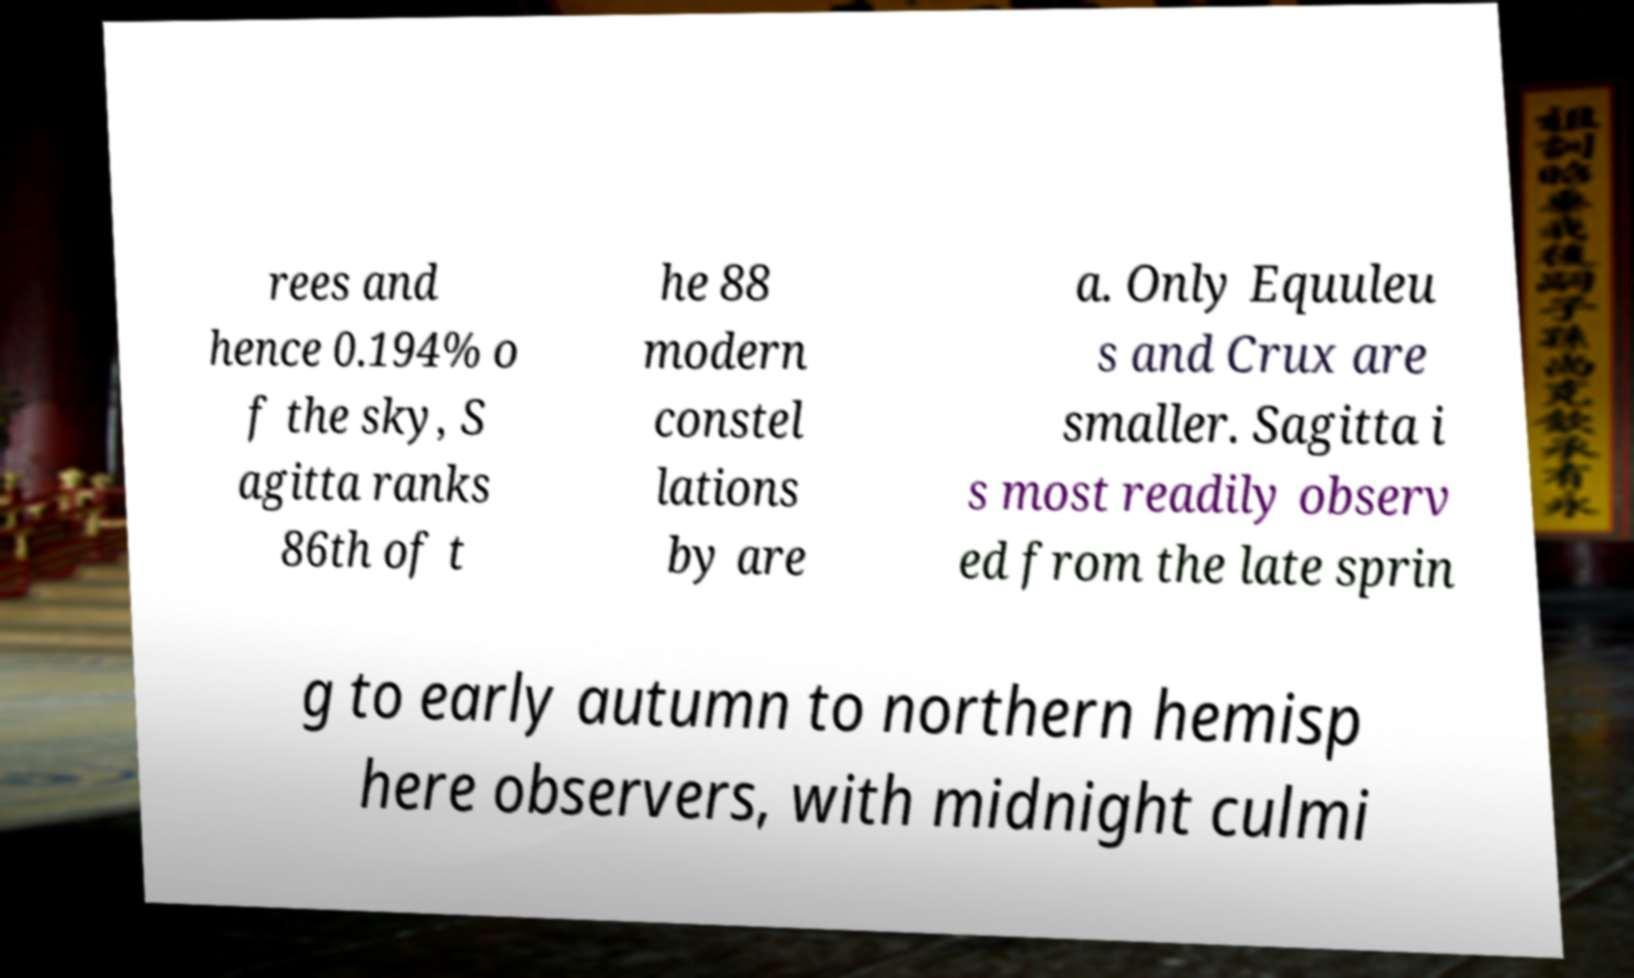I need the written content from this picture converted into text. Can you do that? rees and hence 0.194% o f the sky, S agitta ranks 86th of t he 88 modern constel lations by are a. Only Equuleu s and Crux are smaller. Sagitta i s most readily observ ed from the late sprin g to early autumn to northern hemisp here observers, with midnight culmi 